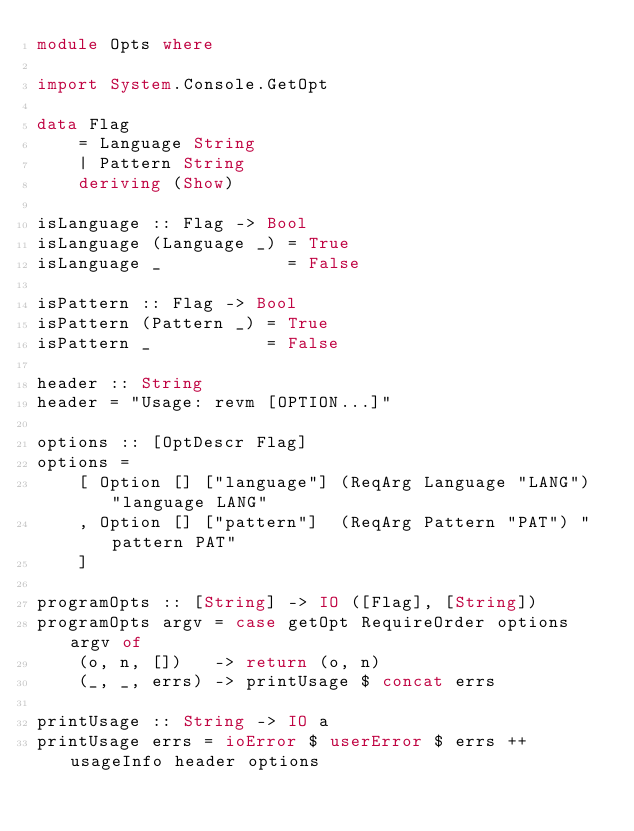Convert code to text. <code><loc_0><loc_0><loc_500><loc_500><_Haskell_>module Opts where

import System.Console.GetOpt

data Flag
    = Language String
    | Pattern String
    deriving (Show)

isLanguage :: Flag -> Bool
isLanguage (Language _) = True
isLanguage _            = False

isPattern :: Flag -> Bool
isPattern (Pattern _) = True
isPattern _           = False

header :: String
header = "Usage: revm [OPTION...]"

options :: [OptDescr Flag]
options =
    [ Option [] ["language"] (ReqArg Language "LANG") "language LANG"
    , Option [] ["pattern"]  (ReqArg Pattern "PAT") "pattern PAT"
    ]

programOpts :: [String] -> IO ([Flag], [String])
programOpts argv = case getOpt RequireOrder options argv of
    (o, n, [])   -> return (o, n)
    (_, _, errs) -> printUsage $ concat errs

printUsage :: String -> IO a
printUsage errs = ioError $ userError $ errs ++ usageInfo header options
</code> 